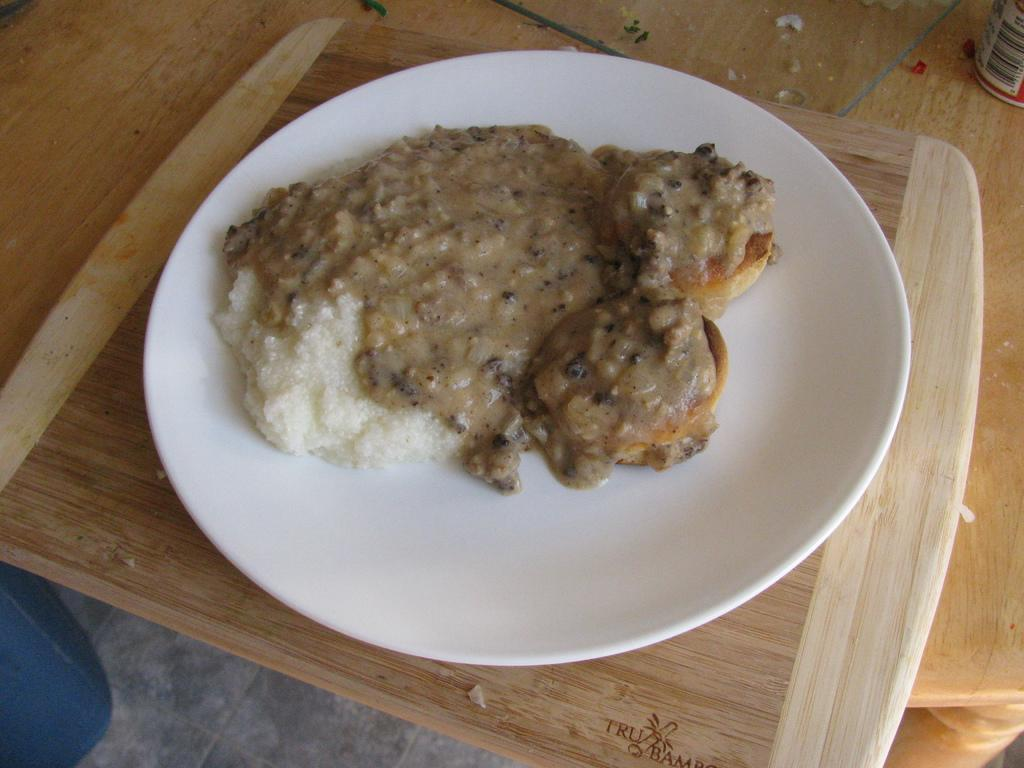What type of food can be seen in the image? The food in the image has brown and cream colors. How is the food arranged in the image? The food is in a plate. What color is the plate? The plate is white. What is the plate resting on in the image? The plate is on a wooden surface. How many sheep are visible in the image? There are no sheep present in the image. What type of card is being used to serve the food in the image? There is no card visible in the image; the food is served on a white plate. 